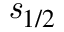Convert formula to latex. <formula><loc_0><loc_0><loc_500><loc_500>{ s } _ { 1 / 2 }</formula> 